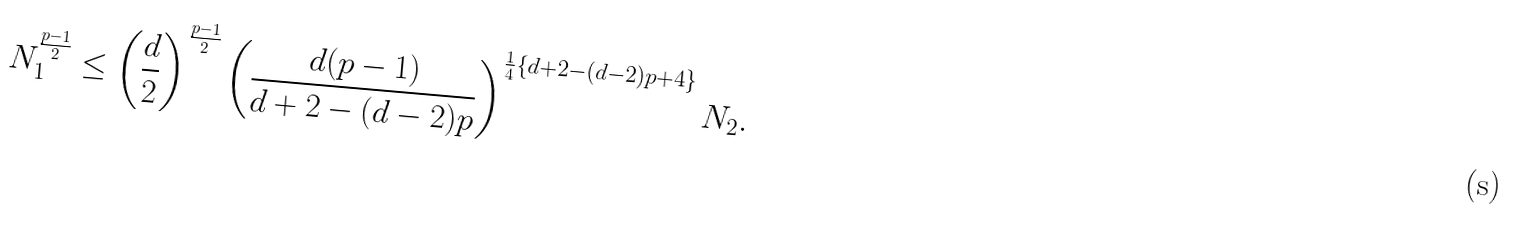Convert formula to latex. <formula><loc_0><loc_0><loc_500><loc_500>N _ { 1 } ^ { \frac { p - 1 } { 2 } } \leq \left ( \frac { d } { 2 } \right ) ^ { \frac { p - 1 } { 2 } } \left ( \frac { d ( p - 1 ) } { d + 2 - ( d - 2 ) p } \right ) ^ { \frac { 1 } { 4 } \left \{ d + 2 - ( d - 2 ) p + 4 \right \} } N _ { 2 } .</formula> 